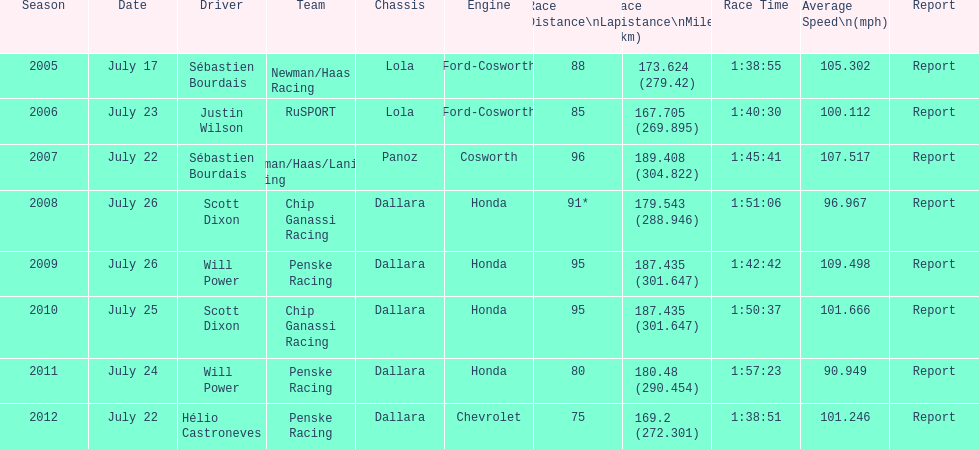What is the total number dallara chassis listed in the table? 5. 